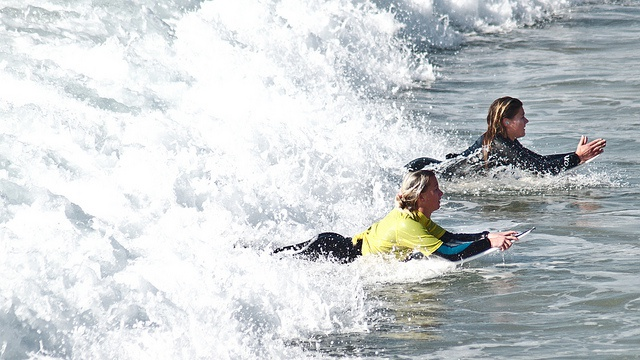Describe the objects in this image and their specific colors. I can see people in white, black, ivory, khaki, and maroon tones, people in white, black, darkgray, lightgray, and gray tones, surfboard in white, darkgray, lightgray, and gray tones, surfboard in white, lightgray, darkgray, and gray tones, and surfboard in white, lightgray, darkgray, and navy tones in this image. 